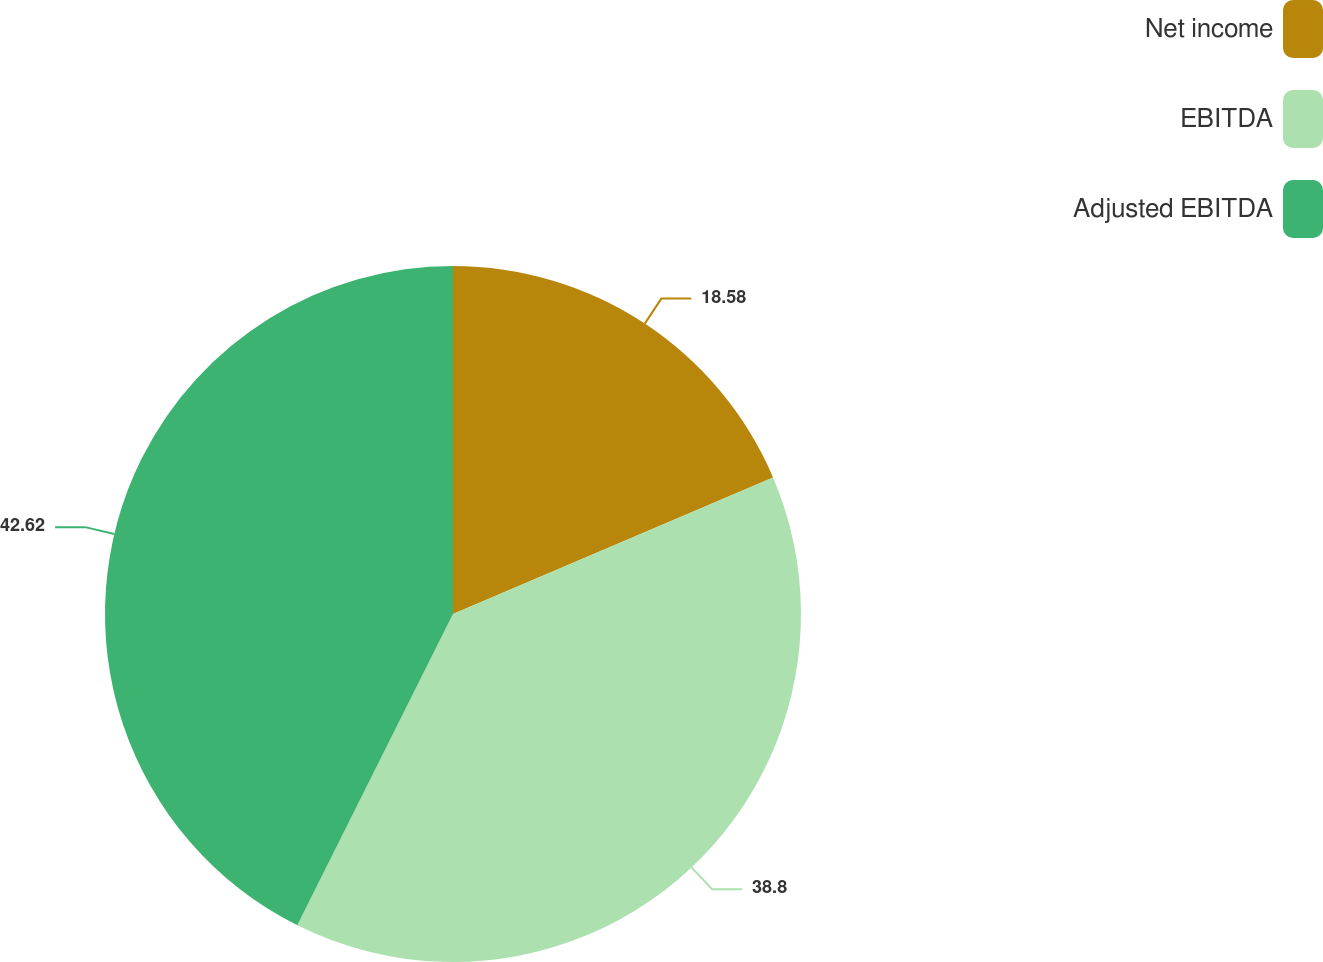<chart> <loc_0><loc_0><loc_500><loc_500><pie_chart><fcel>Net income<fcel>EBITDA<fcel>Adjusted EBITDA<nl><fcel>18.58%<fcel>38.8%<fcel>42.62%<nl></chart> 